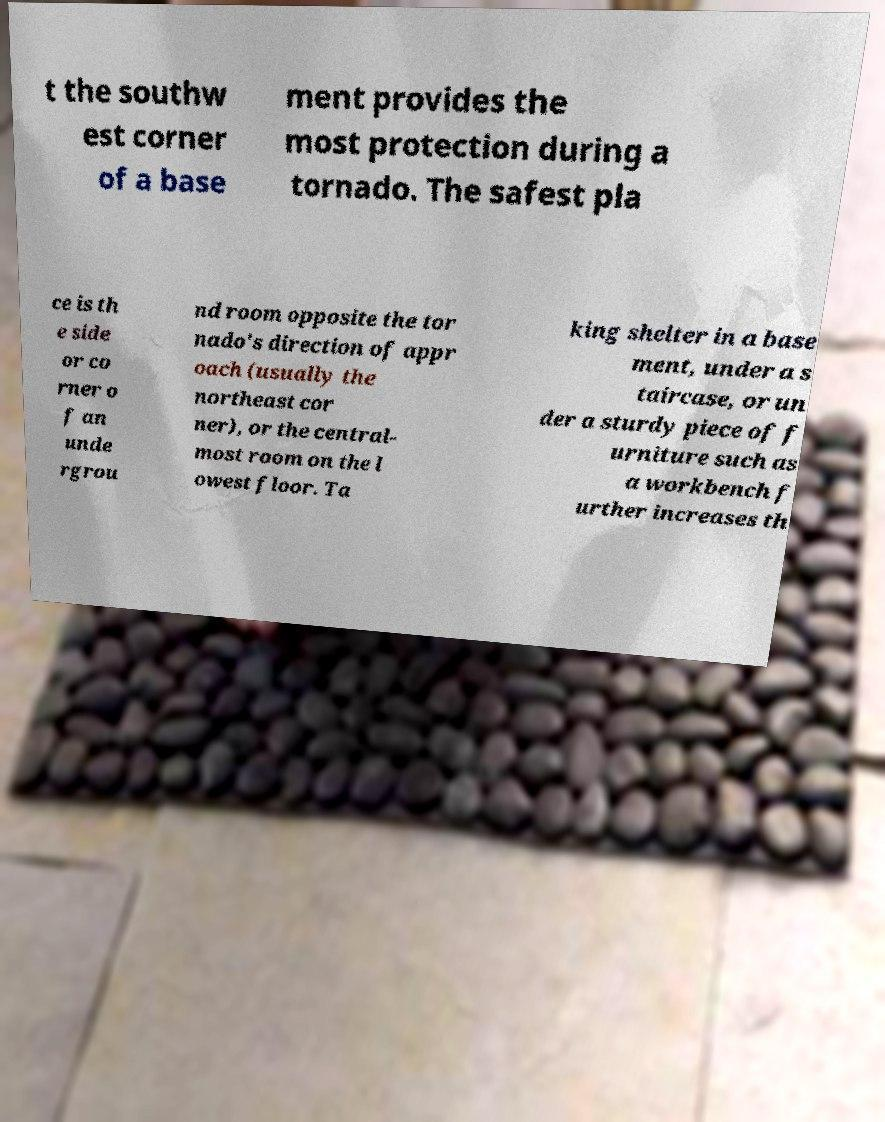For documentation purposes, I need the text within this image transcribed. Could you provide that? t the southw est corner of a base ment provides the most protection during a tornado. The safest pla ce is th e side or co rner o f an unde rgrou nd room opposite the tor nado's direction of appr oach (usually the northeast cor ner), or the central- most room on the l owest floor. Ta king shelter in a base ment, under a s taircase, or un der a sturdy piece of f urniture such as a workbench f urther increases th 